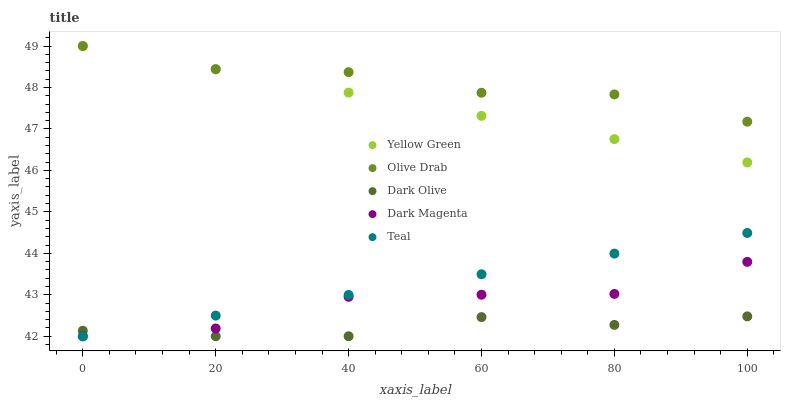Does Dark Olive have the minimum area under the curve?
Answer yes or no. Yes. Does Olive Drab have the maximum area under the curve?
Answer yes or no. Yes. Does Yellow Green have the minimum area under the curve?
Answer yes or no. No. Does Yellow Green have the maximum area under the curve?
Answer yes or no. No. Is Teal the smoothest?
Answer yes or no. Yes. Is Dark Magenta the roughest?
Answer yes or no. Yes. Is Dark Olive the smoothest?
Answer yes or no. No. Is Dark Olive the roughest?
Answer yes or no. No. Does Teal have the lowest value?
Answer yes or no. Yes. Does Yellow Green have the lowest value?
Answer yes or no. No. Does Olive Drab have the highest value?
Answer yes or no. Yes. Does Dark Olive have the highest value?
Answer yes or no. No. Is Dark Magenta less than Olive Drab?
Answer yes or no. Yes. Is Olive Drab greater than Dark Olive?
Answer yes or no. Yes. Does Teal intersect Dark Magenta?
Answer yes or no. Yes. Is Teal less than Dark Magenta?
Answer yes or no. No. Is Teal greater than Dark Magenta?
Answer yes or no. No. Does Dark Magenta intersect Olive Drab?
Answer yes or no. No. 